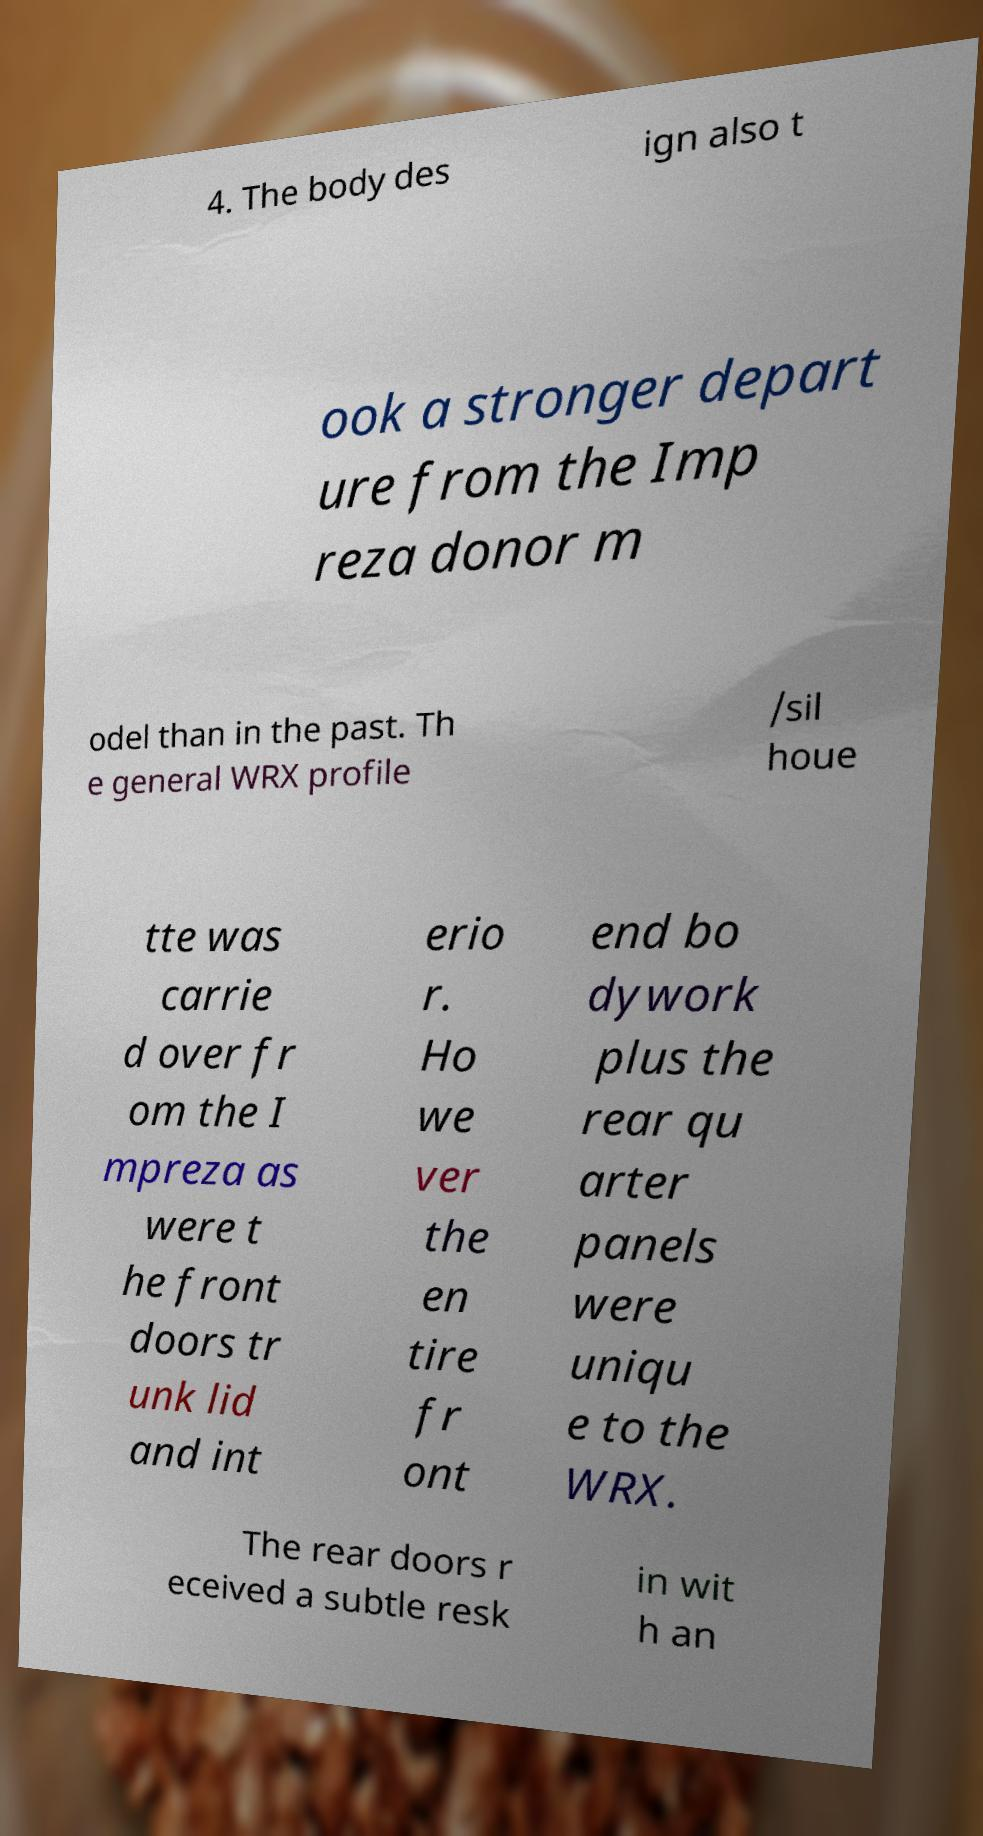There's text embedded in this image that I need extracted. Can you transcribe it verbatim? 4. The body des ign also t ook a stronger depart ure from the Imp reza donor m odel than in the past. Th e general WRX profile /sil houe tte was carrie d over fr om the I mpreza as were t he front doors tr unk lid and int erio r. Ho we ver the en tire fr ont end bo dywork plus the rear qu arter panels were uniqu e to the WRX. The rear doors r eceived a subtle resk in wit h an 